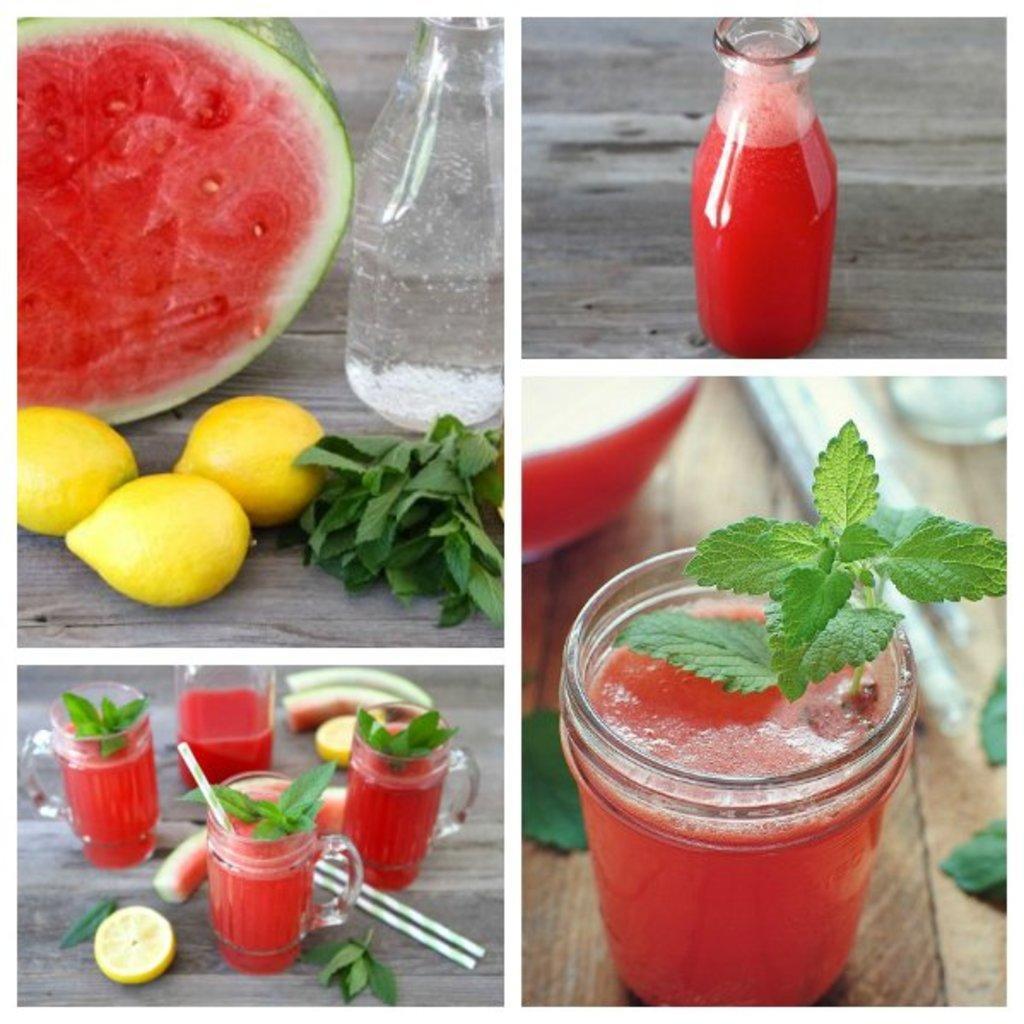How would you summarize this image in a sentence or two? This is a photo collage, we can see watermelon, lemons and glass in the photos. 